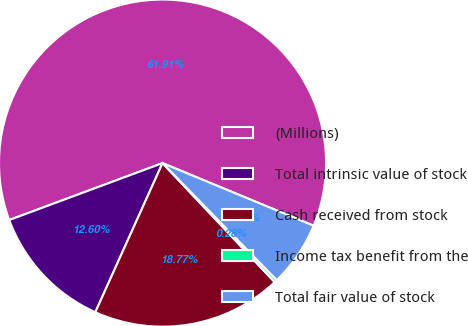Convert chart to OTSL. <chart><loc_0><loc_0><loc_500><loc_500><pie_chart><fcel>(Millions)<fcel>Total intrinsic value of stock<fcel>Cash received from stock<fcel>Income tax benefit from the<fcel>Total fair value of stock<nl><fcel>61.91%<fcel>12.6%<fcel>18.77%<fcel>0.28%<fcel>6.44%<nl></chart> 